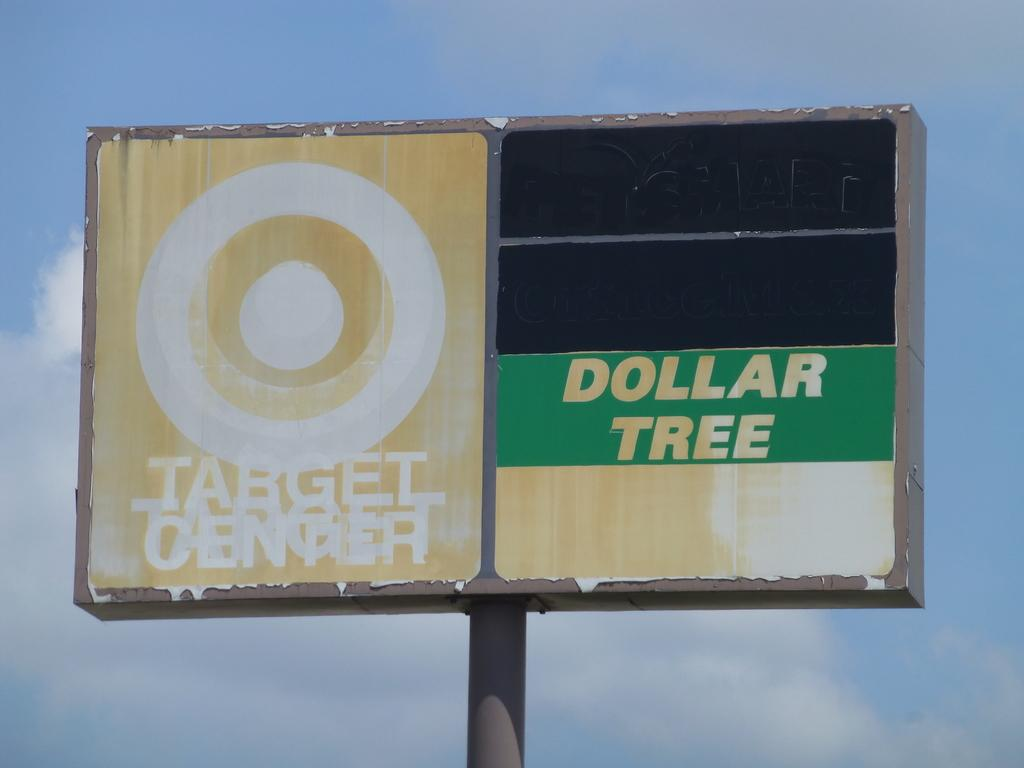<image>
Relay a brief, clear account of the picture shown. Dollar Tree and Targer center logos on a pole. 